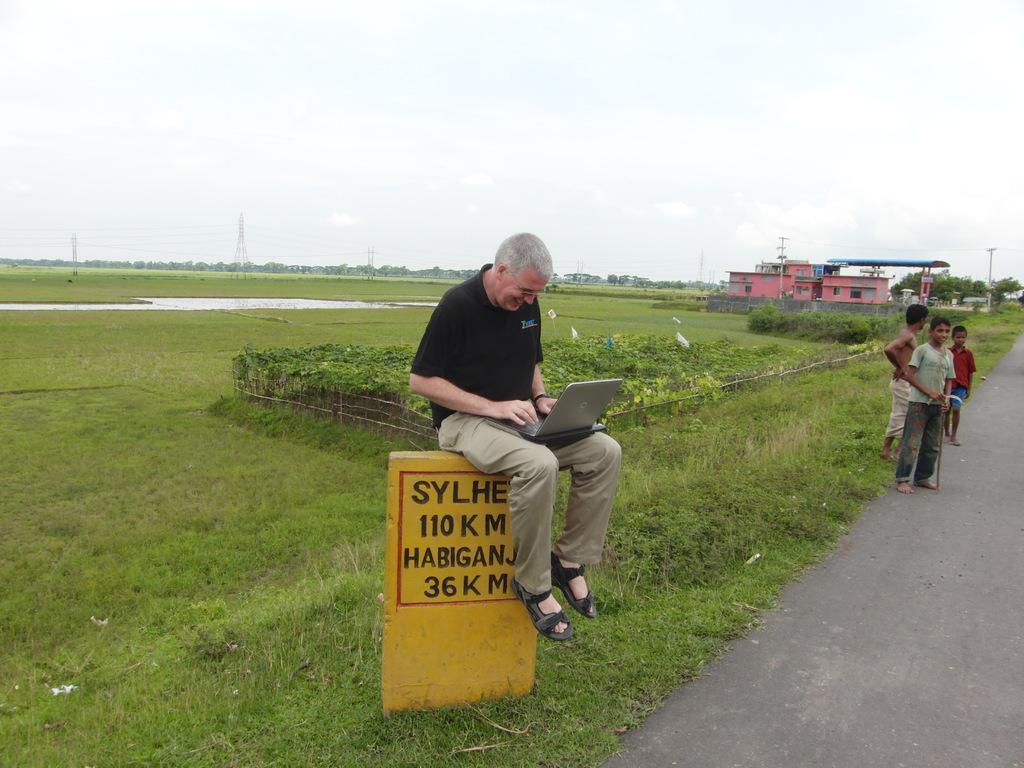How would you summarize this image in a sentence or two? In the middle of the image a person is sitting on a wall and holding a laptop. Behind him there are some plants and water and grass. On the right side of the image three children are standing and holding sticks. Behind them there are some buildings and poles and trees. At the top of the image there is sky. 